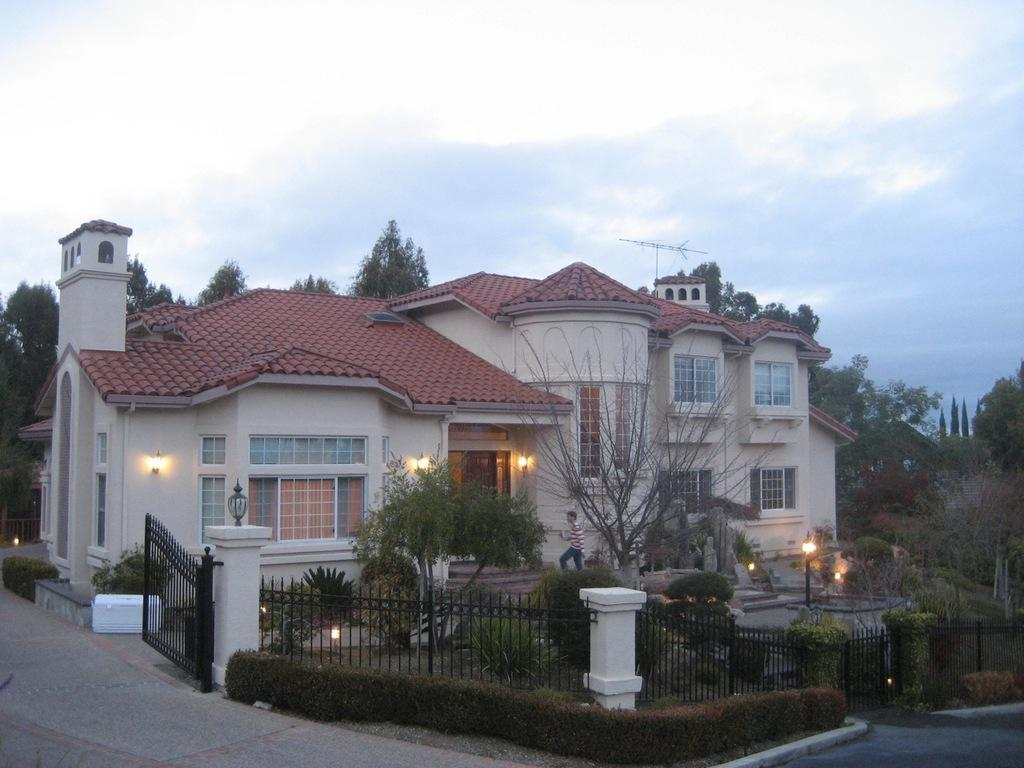What is the main structure in the center of the image? There is a building in the center of the image. What is located at the bottom of the image? There is a road at the bottom of the image. What type of barrier can be seen in the image? There is a fence in the image. Can you describe a specific feature of the fence? There is a gate in the image. What is the person in the image doing? There is a person walking in the image. What celestial objects are visible in the image? Stars are visible in the image. What type of vegetation is present in the image? There are trees in the image. What type of illumination is present in the image? Lights are present in the image. What part of the natural environment is visible in the image? The sky is visible in the image. What type of cup does the representative hold while talking to their daughter in the image? There is no representative or daughter present in the image, and therefore no such interaction or object can be observed. 